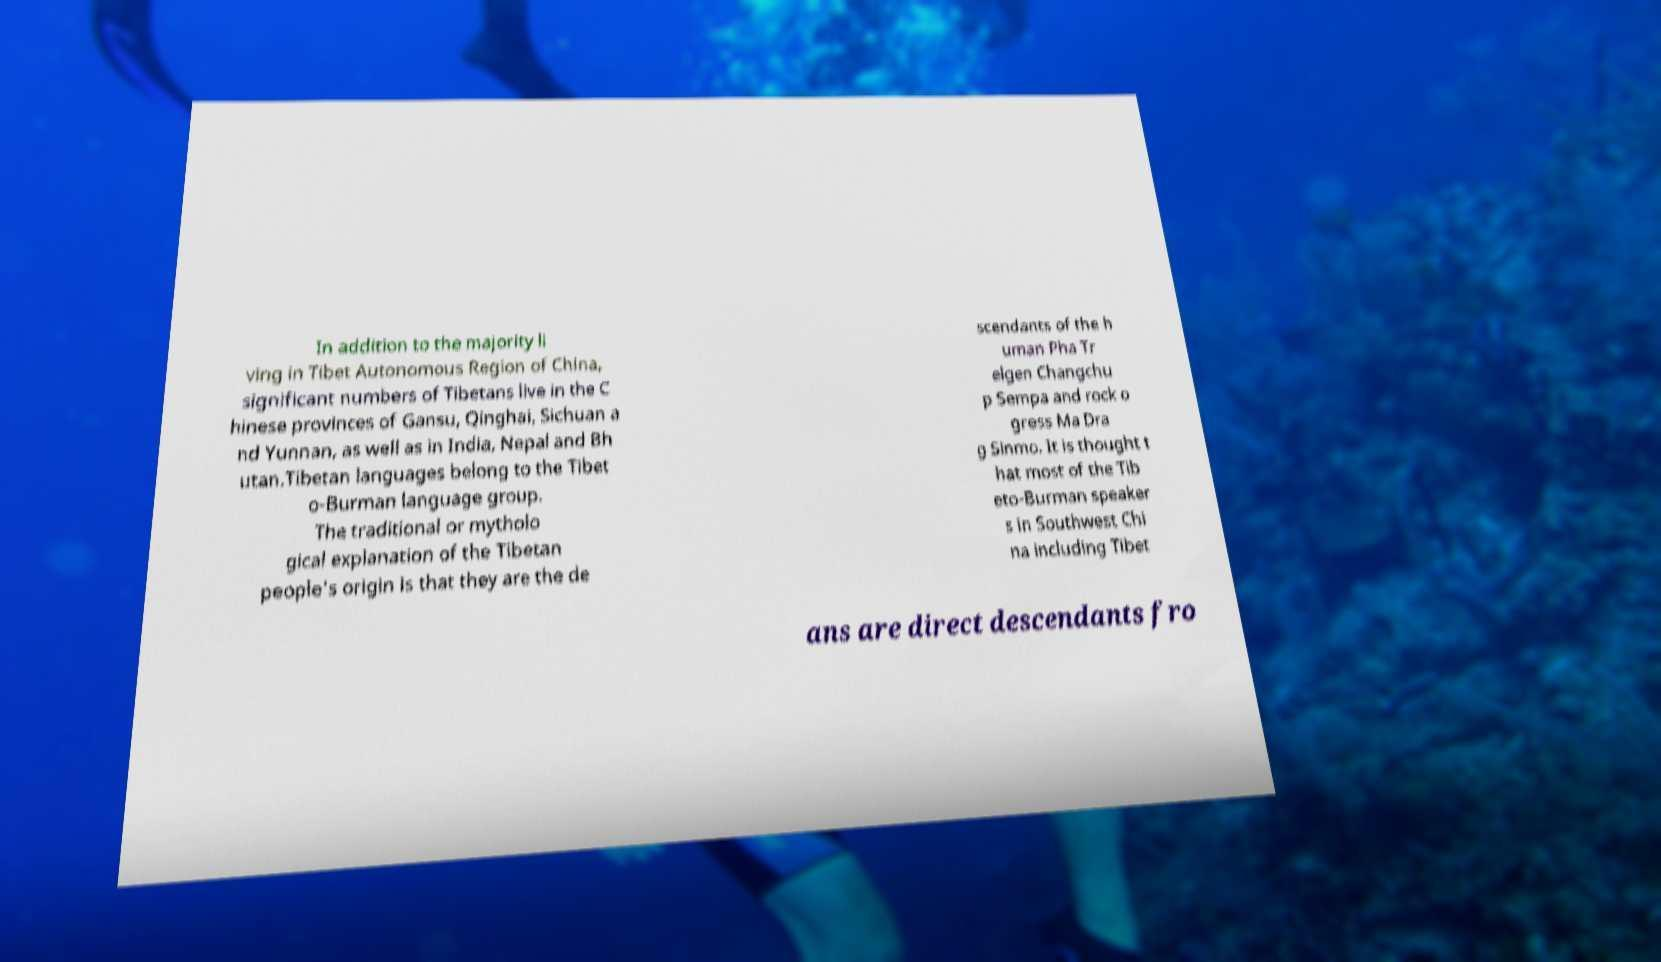I need the written content from this picture converted into text. Can you do that? In addition to the majority li ving in Tibet Autonomous Region of China, significant numbers of Tibetans live in the C hinese provinces of Gansu, Qinghai, Sichuan a nd Yunnan, as well as in India, Nepal and Bh utan.Tibetan languages belong to the Tibet o-Burman language group. The traditional or mytholo gical explanation of the Tibetan people's origin is that they are the de scendants of the h uman Pha Tr elgen Changchu p Sempa and rock o gress Ma Dra g Sinmo. It is thought t hat most of the Tib eto-Burman speaker s in Southwest Chi na including Tibet ans are direct descendants fro 